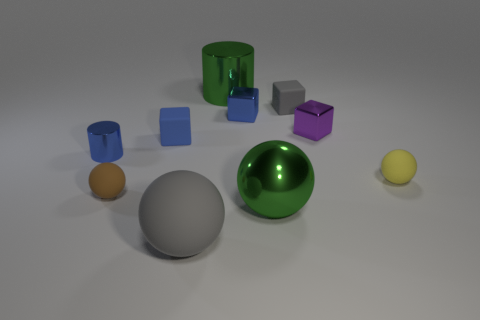Subtract all blue blocks. How many were subtracted if there are1blue blocks left? 1 Subtract all brown balls. How many balls are left? 3 Subtract all yellow cylinders. How many blue blocks are left? 2 Subtract all yellow spheres. How many spheres are left? 3 Subtract 1 cubes. How many cubes are left? 3 Subtract all cyan blocks. Subtract all brown cylinders. How many blocks are left? 4 Subtract all cylinders. How many objects are left? 8 Add 6 tiny brown objects. How many tiny brown objects exist? 7 Subtract 0 red blocks. How many objects are left? 10 Subtract all small gray things. Subtract all big green shiny things. How many objects are left? 7 